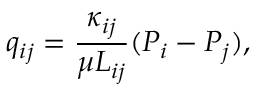<formula> <loc_0><loc_0><loc_500><loc_500>q _ { i j } = \frac { \kappa _ { i j } } { \mu L _ { i j } } ( P _ { i } - P _ { j } ) ,</formula> 